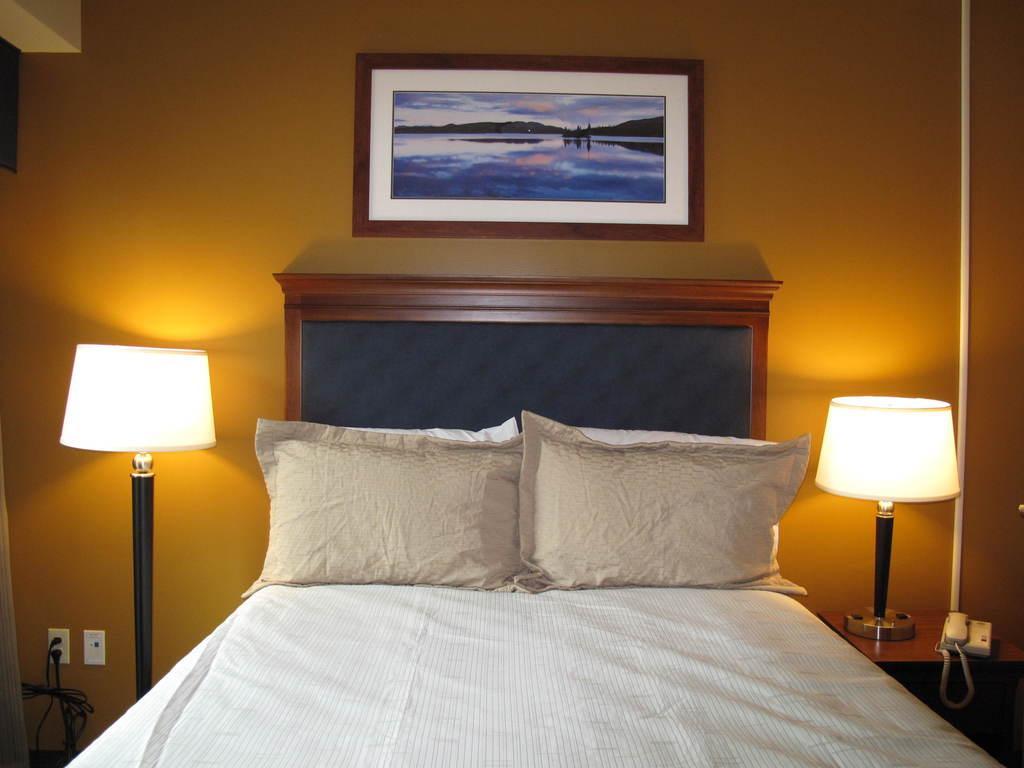Describe this image in one or two sentences. A bedroom is shown in the picture. It has a bed with two pillows,two lamps on either side ,a photo frame on to the wall and a telephone on the table. 